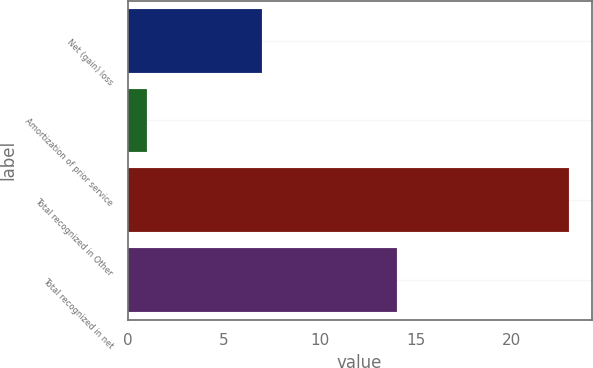<chart> <loc_0><loc_0><loc_500><loc_500><bar_chart><fcel>Net (gain) loss<fcel>Amortization of prior service<fcel>Total recognized in Other<fcel>Total recognized in net<nl><fcel>7<fcel>1<fcel>23<fcel>14<nl></chart> 